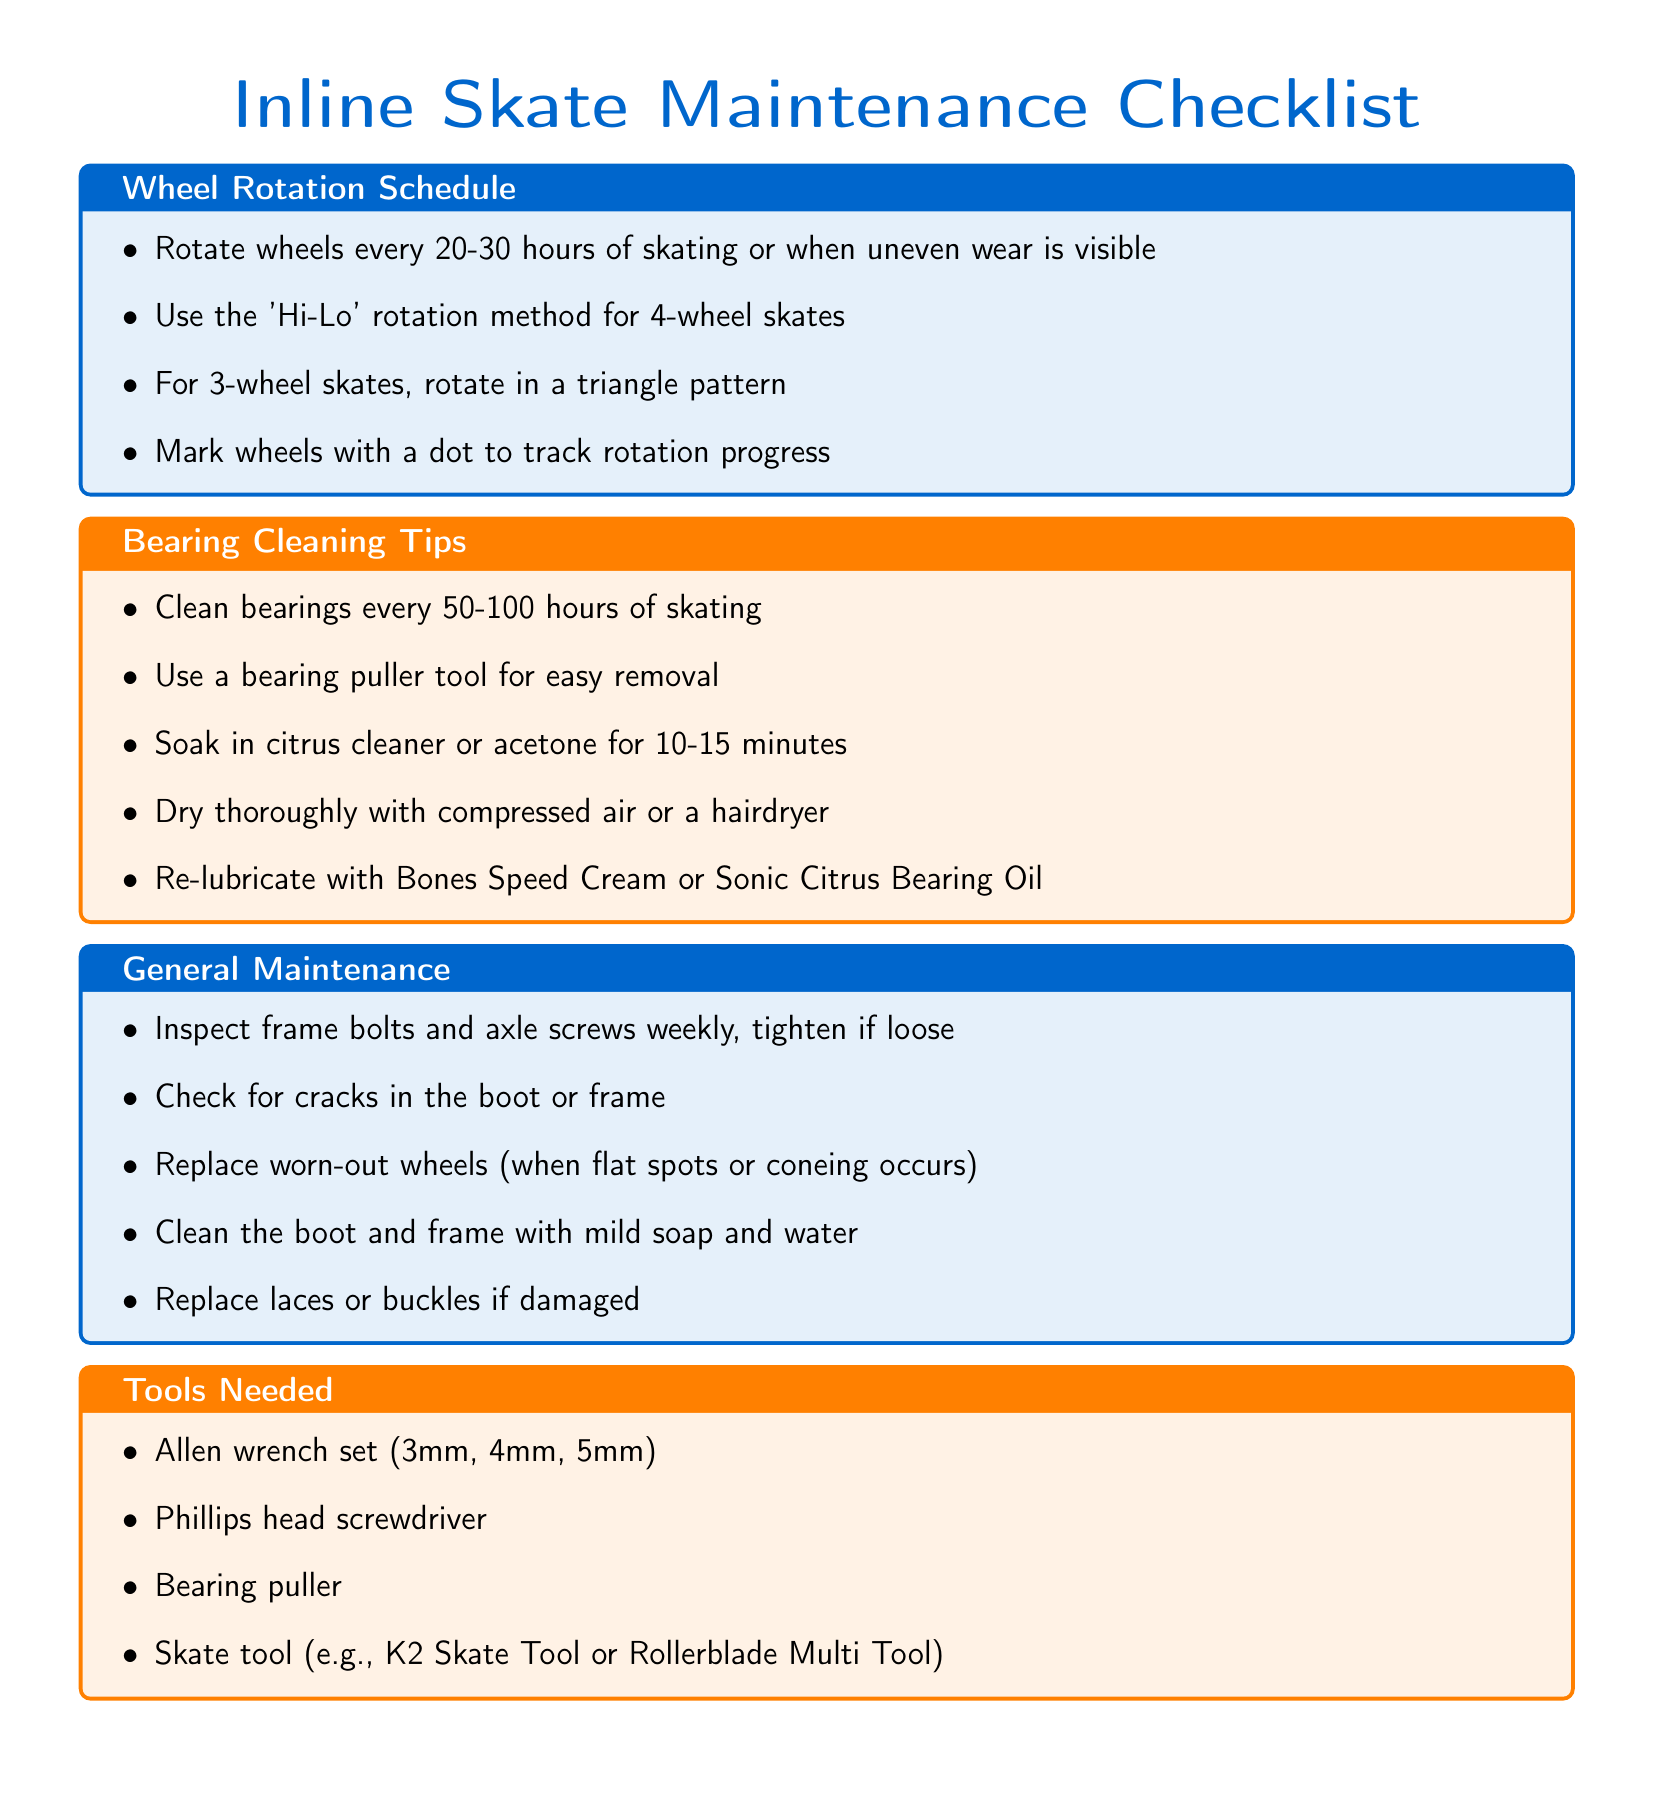What is the wheel rotation frequency? The wheel rotation frequency is specified as every 20-30 hours of skating or when uneven wear is visible.
Answer: every 20-30 hours What cleaning solution is suggested for bearings? The document suggests soaking bearings in citrus cleaner or acetone for cleaning.
Answer: citrus cleaner or acetone What pattern should be used for rotating 3-wheel skates? The pattern specified for rotating 3-wheel skates is in a triangle pattern.
Answer: triangle pattern How often should you check frame bolts and axle screws? The document states that frame bolts and axle screws should be inspected weekly.
Answer: weekly What tool is mentioned for easy bearing removal? The bearing puller tool is mentioned as a tool for easy removal of bearings.
Answer: bearing puller How many different maintenance categories are listed in the document? The document lists four different maintenance categories: Wheel Rotation Schedule, Bearing Cleaning Tips, General Maintenance, and Tools Needed.
Answer: four What should you do with worn-out wheels? According to the document, worn-out wheels should be replaced when flat spots or coneing occurs.
Answer: replace What is one item included in the tools needed section? The tools needed section includes an Allen wrench set (3mm, 4mm, 5mm) as one of the items.
Answer: Allen wrench set What type of maintenance is suggested every 50-100 hours? The document suggests cleaning bearings every 50-100 hours of skating.
Answer: cleaning bearings 